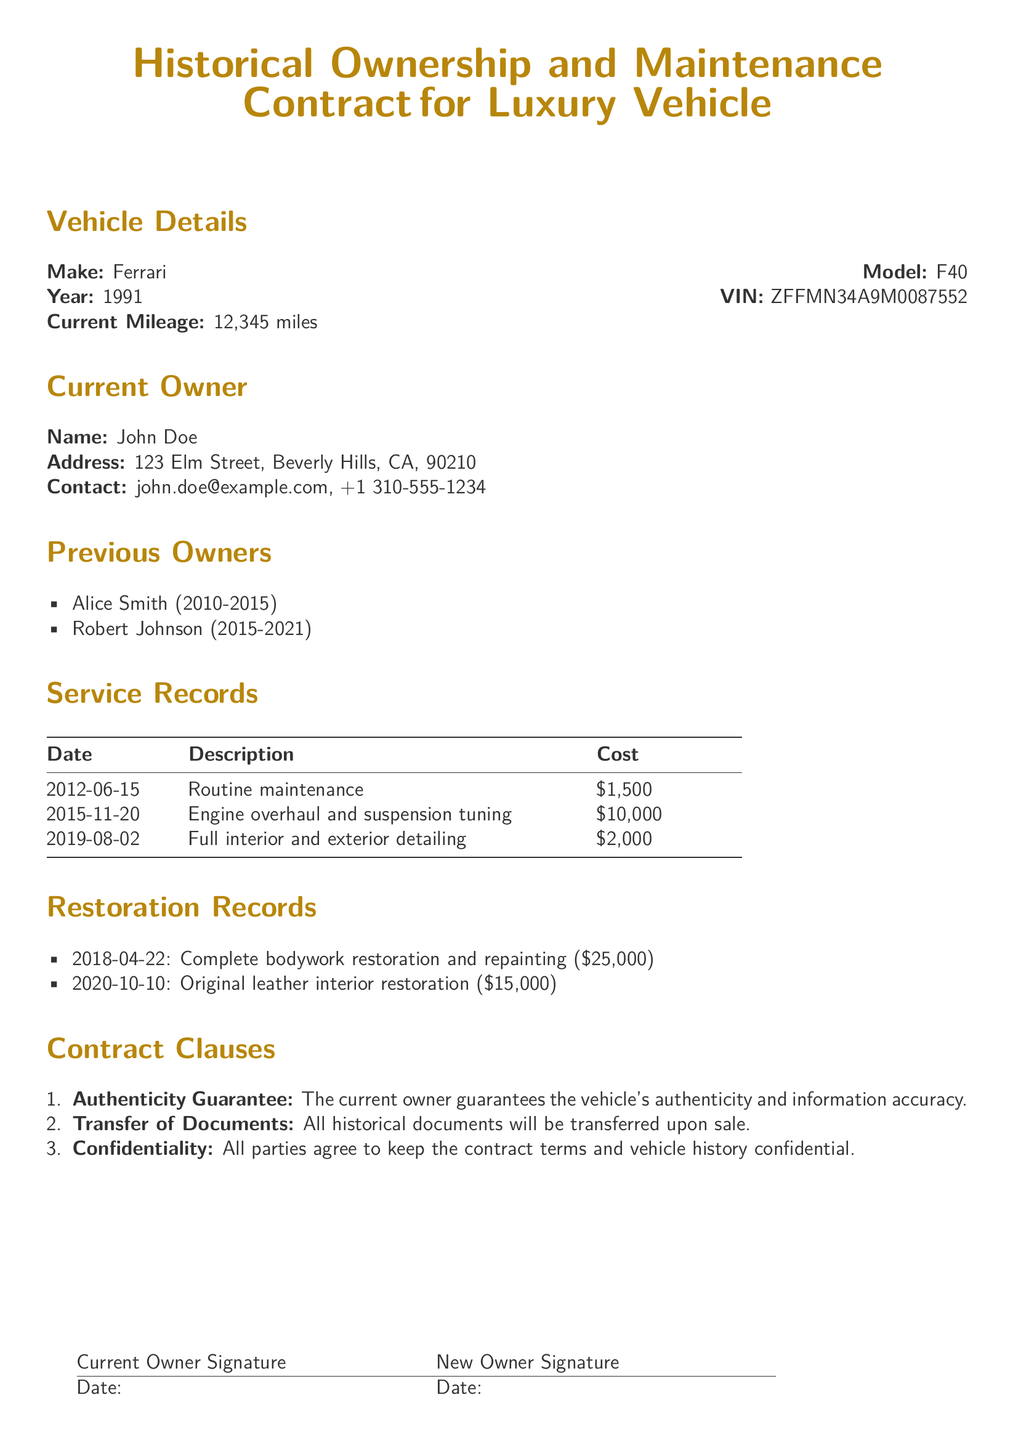What is the make of the vehicle? The make of the vehicle is listed in the document under Vehicle Details.
Answer: Ferrari Who is the current owner? The current owner's name is specified in the Current Owner section of the document.
Answer: John Doe What year was the vehicle manufactured? The year of manufacture can be found in the Vehicle Details section of the document.
Answer: 1991 What was the cost of the engine overhaul and suspension tuning? The cost of the engine overhaul and suspension tuning is detailed in the Service Records.
Answer: $10,000 What restoration work was performed on 2020-10-10? The restoration work performed on this date is mentioned in the Restoration Records.
Answer: Original leather interior restoration How many previous owners has the vehicle had? The number of previous owners can be determined by counting the list in the Previous Owners section.
Answer: 2 What is guaranteed by the current owner according to the contract? The contract specifies what the current owner guarantees, found in the Contract Clauses section.
Answer: Authenticity What is the total cost of service records listed? To find the total cost, sum the costs listed in the Service Records.
Answer: $13,500 What will happen to historical documents upon sale? The document specifies what happens to historical documents in one of the Contract Clauses.
Answer: Transferred upon sale 